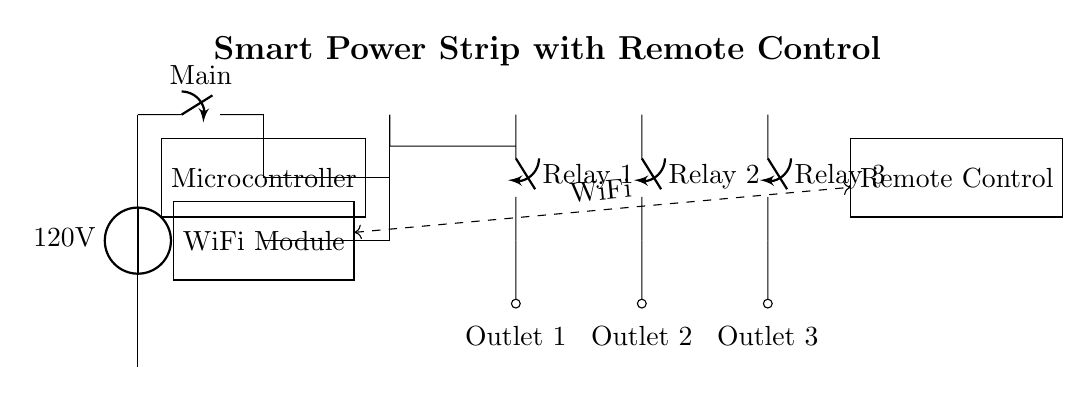What is the power source voltage? The power source voltage is indicated in the circuit diagram as 120 volts. This information is presented next to the voltage source symbol at the top of the circuit.
Answer: 120V What components control the outlets? The outlets are controlled by relay switches, which are indicated in the diagram. Each relay switch corresponds to an outlet, allowing for management of for multiple devices.
Answer: Relay switches How many outlets are present in this smart power strip? The diagram shows three distinct outlets, each represented by separate connection points labeled as Outlet 1, Outlet 2, and Outlet 3.
Answer: Three What is the function of the microcontroller? The microcontroller manages the control signals for the relays, enabling communication between the remote control and the outlets. It interprets the commands sent from the remote to operate the relays accordingly.
Answer: Management of control signals How does the remote control connect to the circuit? The remote control connects to the WiFi module, which is embodied in the circuit as a dashed line indicating wireless communication. This implies that the remote sends signals to the WiFi module, which then communicates with the microcontroller to control the relays.
Answer: Wireless connection via WiFi What role does the WiFi module play in the circuit? The WiFi module facilitates wireless communication between the remote control and the microcontroller. It receives signals from the remote and sends them to the microcontroller for processing, making remote operation of the power strip possible.
Answer: Facilitates wireless communication 